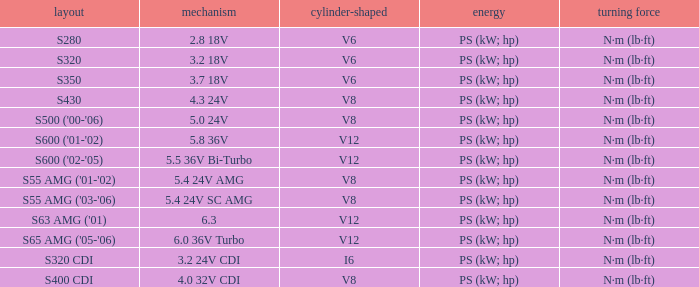Which Engine has a Model of s430? 4.3 24V. 